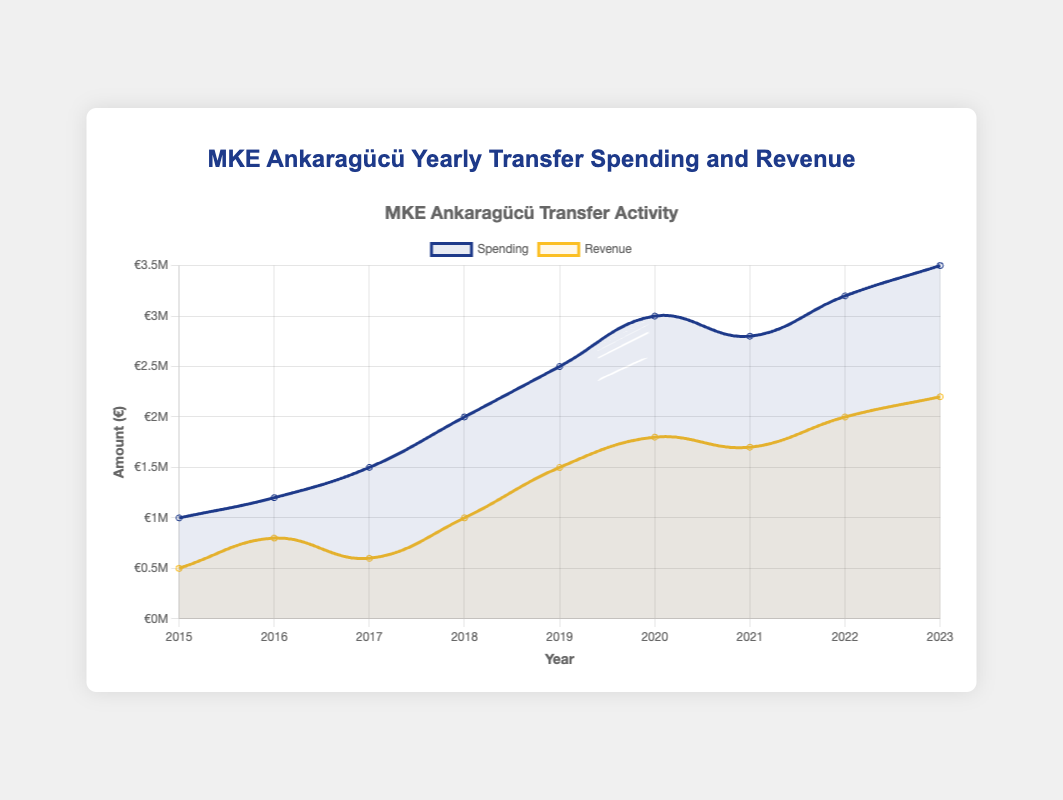What was the spending in 2018? Refer to the chart and locate the value for spending in 2018.
Answer: €2,000,000 How much more was spent in 2023 compared to 2015? Subtract the spending in 2015 from the spending in 2023 (€3,500,000 - €1,000,000).
Answer: €2,500,000 In which year was the revenue the lowest? Review the chart and find the smallest revenue value.
Answer: 2015 What is the average spending from 2019 to 2023? Sum the spending from 2019 to 2023 and divide by 5. (2,500,000 + 3,000,000 + 2,800,000 + 3,200,000 + 3,500,000) / 5.
Answer: €3,000,000 How did spending change from 2020 to 2021? Compare the spending values for 2020 and 2021 to see if there is an increase or decrease (3,000,000 in 2020 vs 2,800,000 in 2021).
Answer: Decreased Was the spending in 2016 more than the revenue in 2016? Compare the spending and revenue values in 2016 (1,200,000 vs 800,000).
Answer: Yes In which year was the difference between spending and revenue the greatest? Calculate the difference between spending and revenue for each year and find the maximum (2,000,000 in 2020: 3,000,000 - 1,000,000).
Answer: 2020 How much did revenue increase from 2018 to 2019? Subtract the revenue in 2018 from the revenue in 2019 (1,500,000 - 1,000,000).
Answer: €500,000 Between which consecutive years did the spending increase the most? Calculate the difference in spending between each consecutive year and find the maximum increment (2017 to 2018: 2,000,000 - 1,500,000 = 500,000).
Answer: 2017-2018 What color represents spending in the chart? Observe the color used for the spending line in the chart.
Answer: Blue 